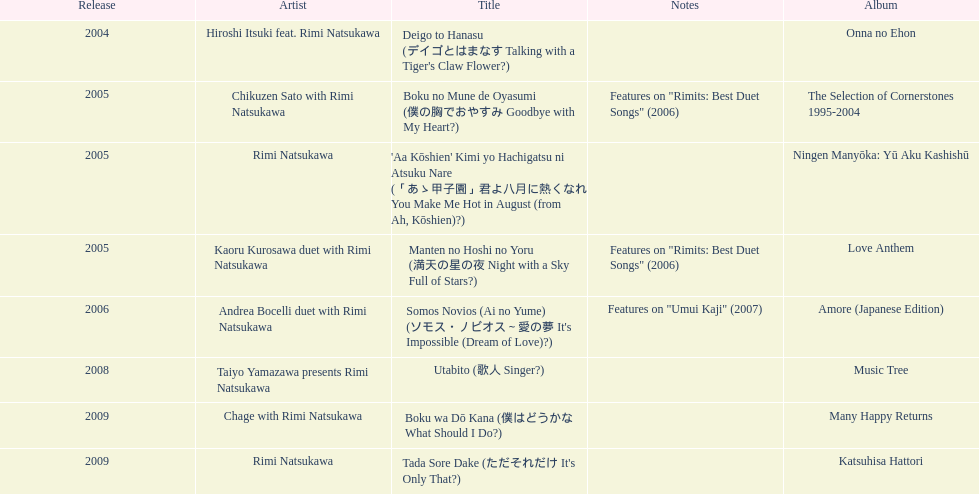How many titles are attributed to a single artist? 2. 